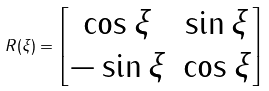<formula> <loc_0><loc_0><loc_500><loc_500>R ( \xi ) = \begin{bmatrix} \cos \xi & \sin \xi \\ - \sin \xi & \cos \xi \end{bmatrix}</formula> 